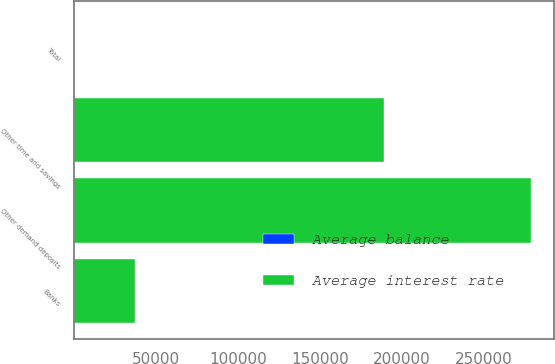Convert chart to OTSL. <chart><loc_0><loc_0><loc_500><loc_500><stacked_bar_chart><ecel><fcel>Banks<fcel>Other demand deposits<fcel>Other time and savings<fcel>Total<nl><fcel>Average balance<fcel>0.34<fcel>0.49<fcel>1.16<fcel>0.73<nl><fcel>Average interest rate<fcel>36983<fcel>278745<fcel>189049<fcel>1.16<nl></chart> 